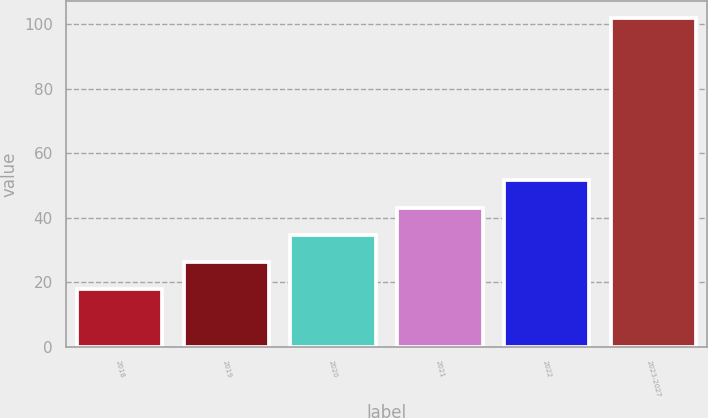Convert chart to OTSL. <chart><loc_0><loc_0><loc_500><loc_500><bar_chart><fcel>2018<fcel>2019<fcel>2020<fcel>2021<fcel>2022<fcel>2023-2027<nl><fcel>18<fcel>26.4<fcel>34.8<fcel>43.2<fcel>51.6<fcel>102<nl></chart> 